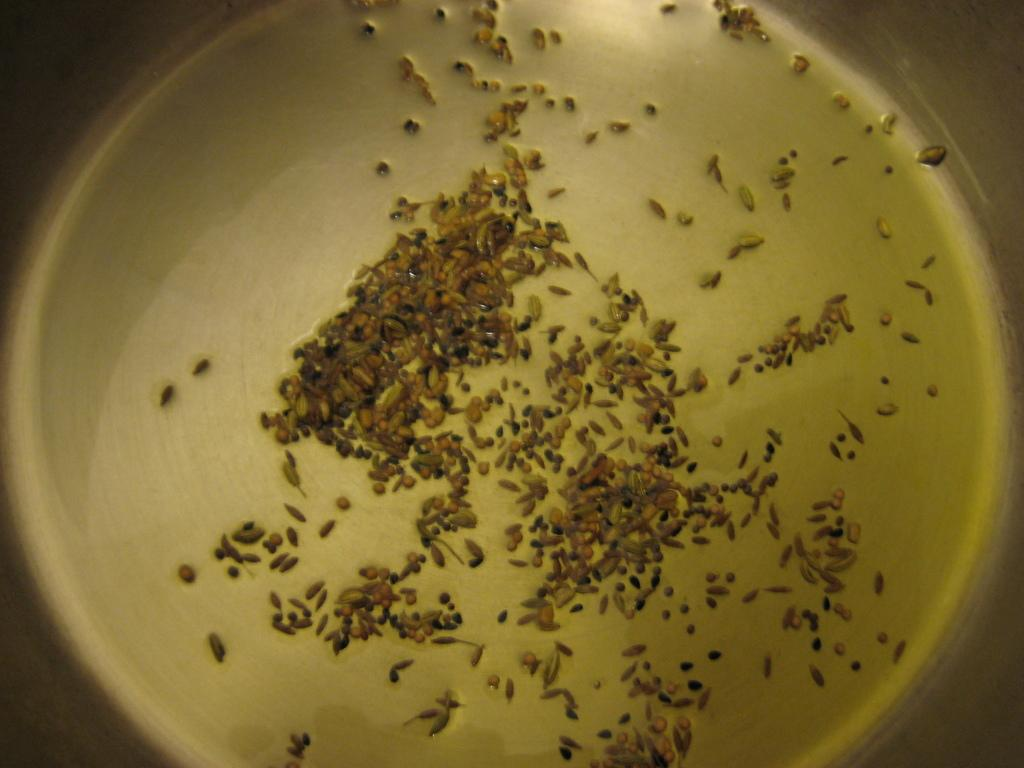What is present in the image? There is a bowl in the image. What is inside the bowl? The bowl contains ingredients. How many patches can be seen on the mother's clothing in the image? There is no mother or clothing present in the image; it only features a bowl with ingredients. 